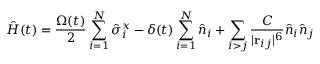Convert formula to latex. <formula><loc_0><loc_0><loc_500><loc_500>\hat { H } ( t ) = \frac { \Omega ( t ) } { 2 } \sum _ { i = 1 } ^ { N } \hat { \sigma } _ { i } ^ { x } - \delta ( t ) \sum _ { i = 1 } ^ { N } \hat { n } _ { i } + \sum _ { i > j } \frac { C } { | \mathbf r _ { i j } | ^ { 6 } } \hat { n } _ { i } \hat { n } _ { j }</formula> 